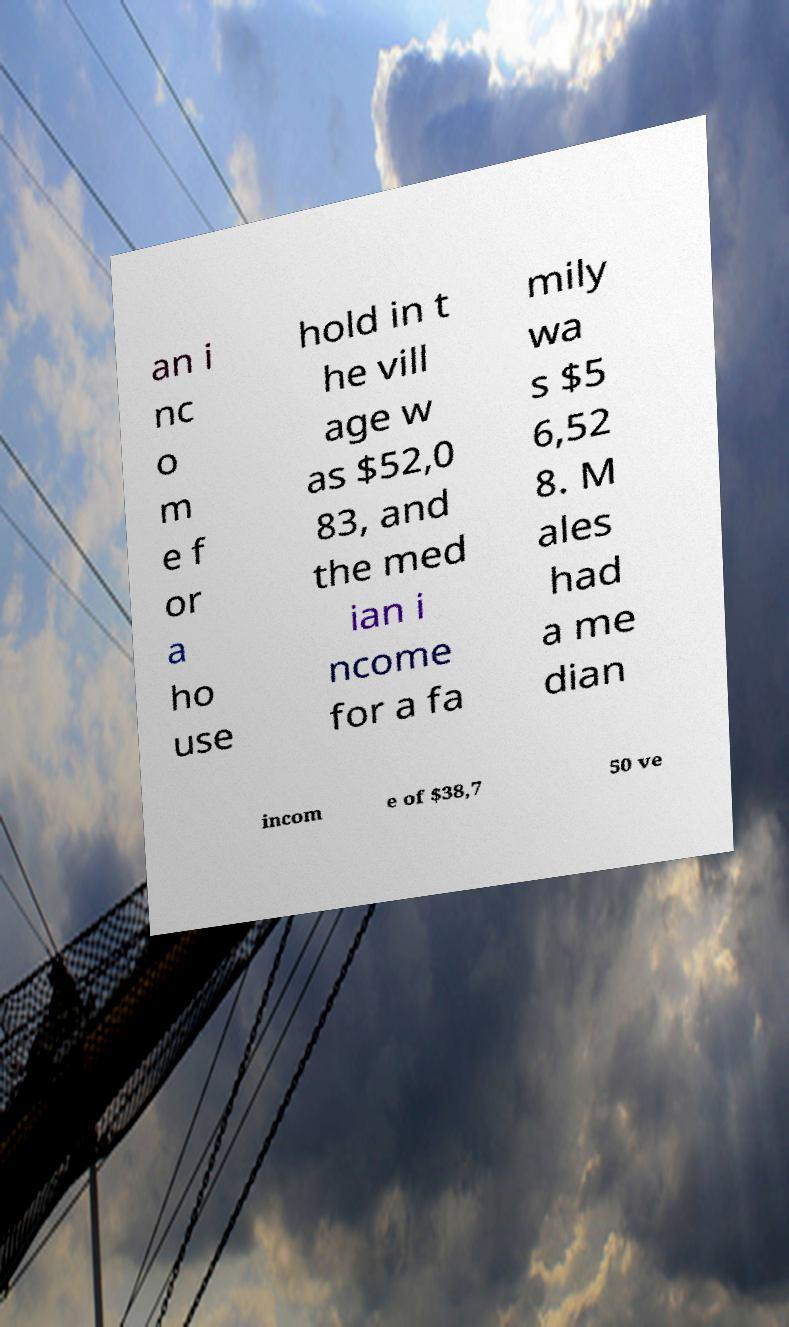There's text embedded in this image that I need extracted. Can you transcribe it verbatim? an i nc o m e f or a ho use hold in t he vill age w as $52,0 83, and the med ian i ncome for a fa mily wa s $5 6,52 8. M ales had a me dian incom e of $38,7 50 ve 